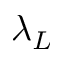<formula> <loc_0><loc_0><loc_500><loc_500>\lambda _ { L }</formula> 